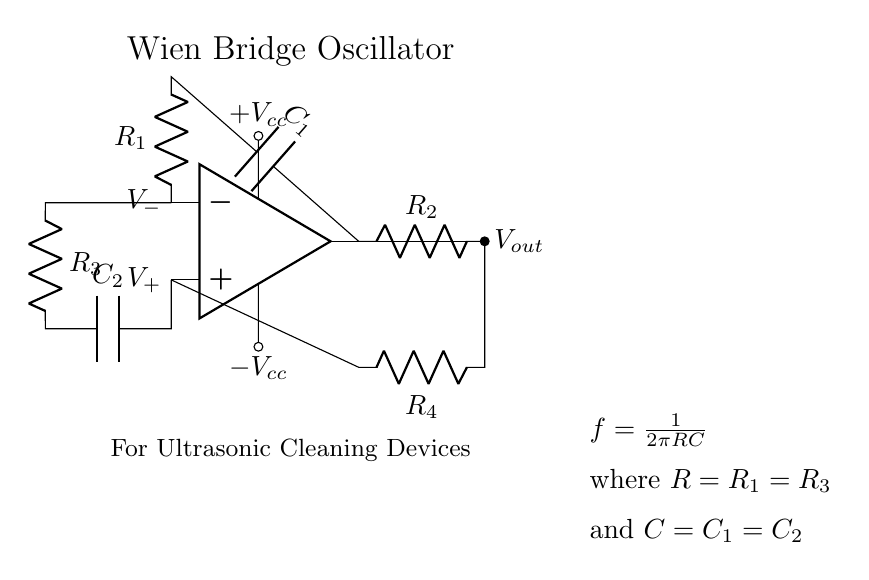What is the primary function of this circuit? This circuit functions as a Wien bridge oscillator, which is used to generate precise frequencies, particularly in ultrasonic cleaning devices.
Answer: Wien bridge oscillator What are the values of the capacitors used in this circuit? The circuit uses two capacitors, C1 and C2, which are equal in value, as indicated by the circuit layout.
Answer: C1 = C2 How many resistors are in the circuit? The circuit contains four resistors, labeled R1, R2, R3, and R4.
Answer: Four What is the relationship between the resistors R1 and R3? In the circuit, R1 and R3 are equal in value as part of the Wien bridge configuration.
Answer: R1 = R3 What determines the frequency output of the oscillator? The frequency output is determined by the values of the resistors and capacitors in the circuit, as captured in the formula: f = 1/(2πRC).
Answer: Values of R and C Which component provides the output voltage? The output voltage, denoted as Vout, is taken from the output terminal of the operational amplifier.
Answer: Operational amplifier 